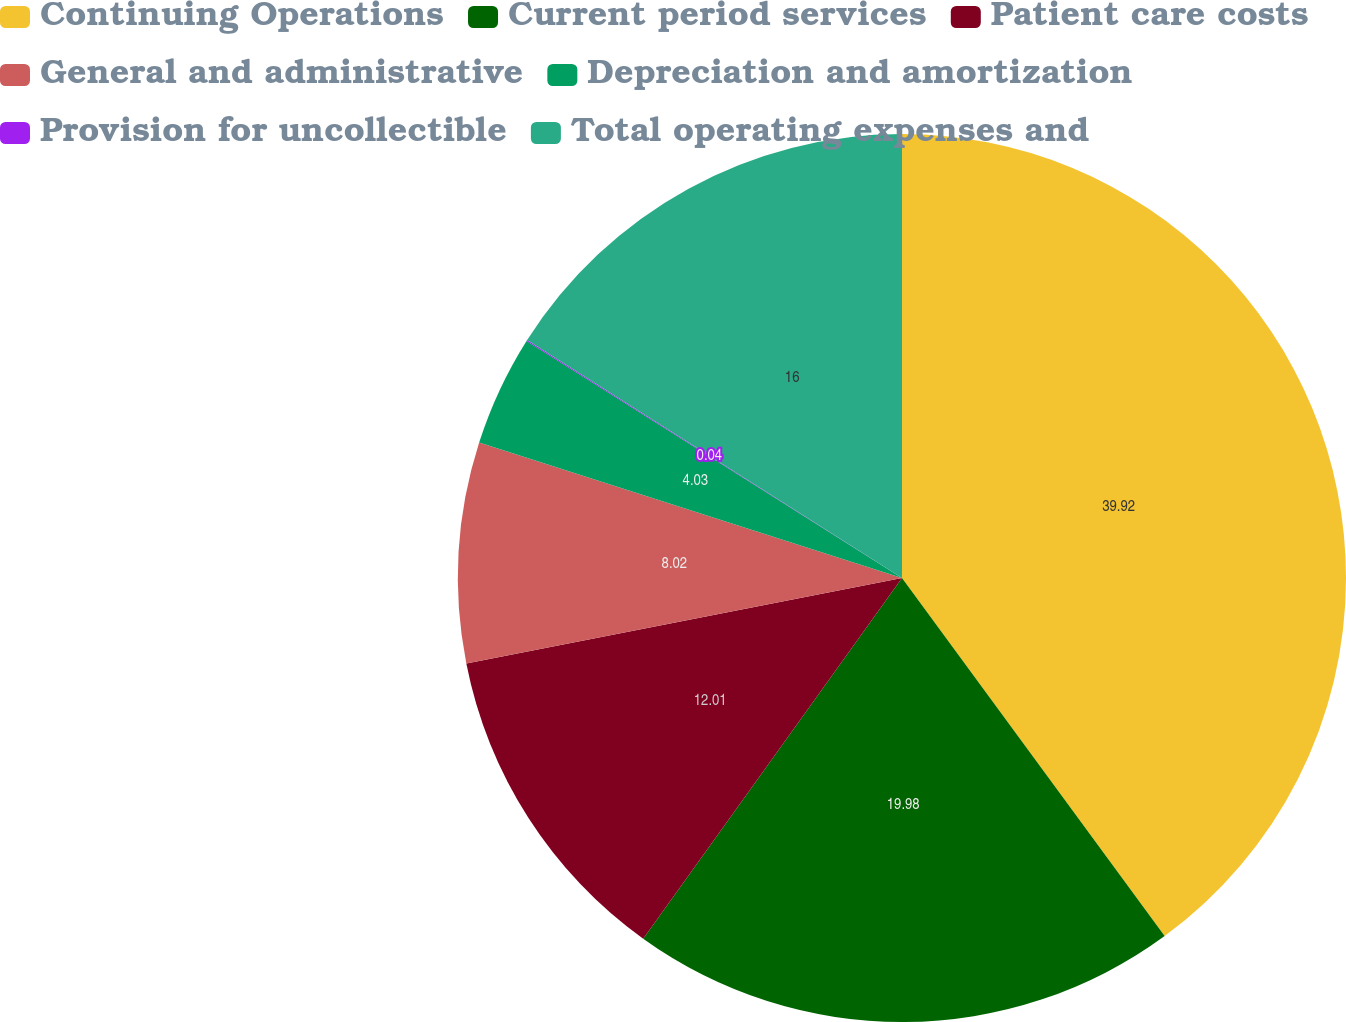<chart> <loc_0><loc_0><loc_500><loc_500><pie_chart><fcel>Continuing Operations<fcel>Current period services<fcel>Patient care costs<fcel>General and administrative<fcel>Depreciation and amortization<fcel>Provision for uncollectible<fcel>Total operating expenses and<nl><fcel>39.93%<fcel>19.98%<fcel>12.01%<fcel>8.02%<fcel>4.03%<fcel>0.04%<fcel>16.0%<nl></chart> 